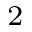Convert formula to latex. <formula><loc_0><loc_0><loc_500><loc_500>^ { 2 }</formula> 